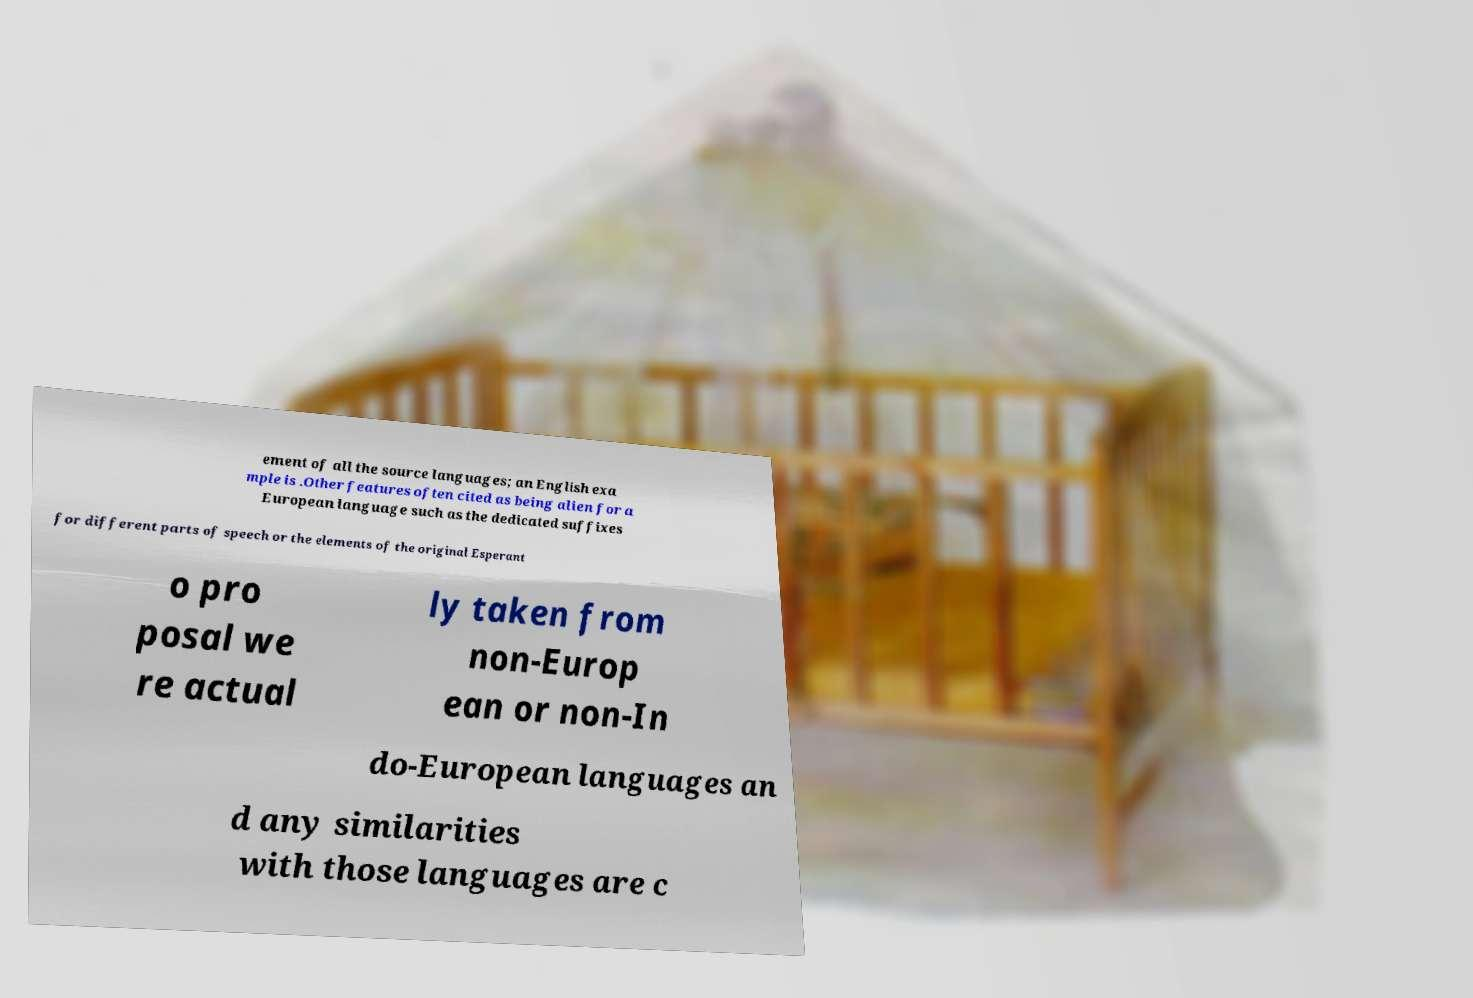Please read and relay the text visible in this image. What does it say? ement of all the source languages; an English exa mple is .Other features often cited as being alien for a European language such as the dedicated suffixes for different parts of speech or the elements of the original Esperant o pro posal we re actual ly taken from non-Europ ean or non-In do-European languages an d any similarities with those languages are c 